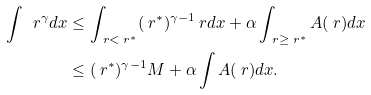<formula> <loc_0><loc_0><loc_500><loc_500>\int \ r ^ { \gamma } d x & \leq \int _ { \ r < \ r ^ { * } } ( \ r ^ { * } ) ^ { \gamma - 1 } \ r d x + \alpha \int _ { \ r \geq \ r ^ { * } } A ( \ r ) d x \\ & \leq ( \ r ^ { * } ) ^ { \gamma - 1 } M + \alpha \int A ( \ r ) d x .</formula> 